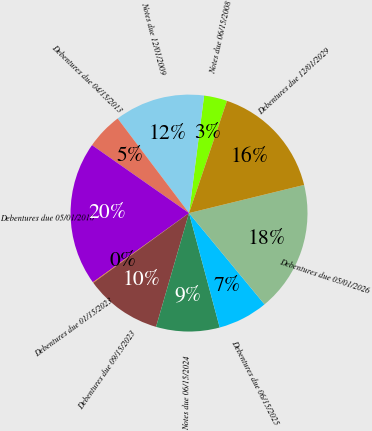<chart> <loc_0><loc_0><loc_500><loc_500><pie_chart><fcel>Notes due 06/15/2008<fcel>Notes due 12/01/2009<fcel>Debentures due 04/15/2013<fcel>Debentures due 05/01/2016<fcel>Debentures due 01/15/2023<fcel>Debentures due 09/15/2023<fcel>Notes due 06/15/2024<fcel>Debentures due 06/15/2025<fcel>Debentures due 05/01/2026<fcel>Debentures due 12/01/2029<nl><fcel>3.16%<fcel>12.32%<fcel>4.99%<fcel>19.65%<fcel>0.09%<fcel>10.49%<fcel>8.66%<fcel>6.83%<fcel>17.82%<fcel>15.99%<nl></chart> 